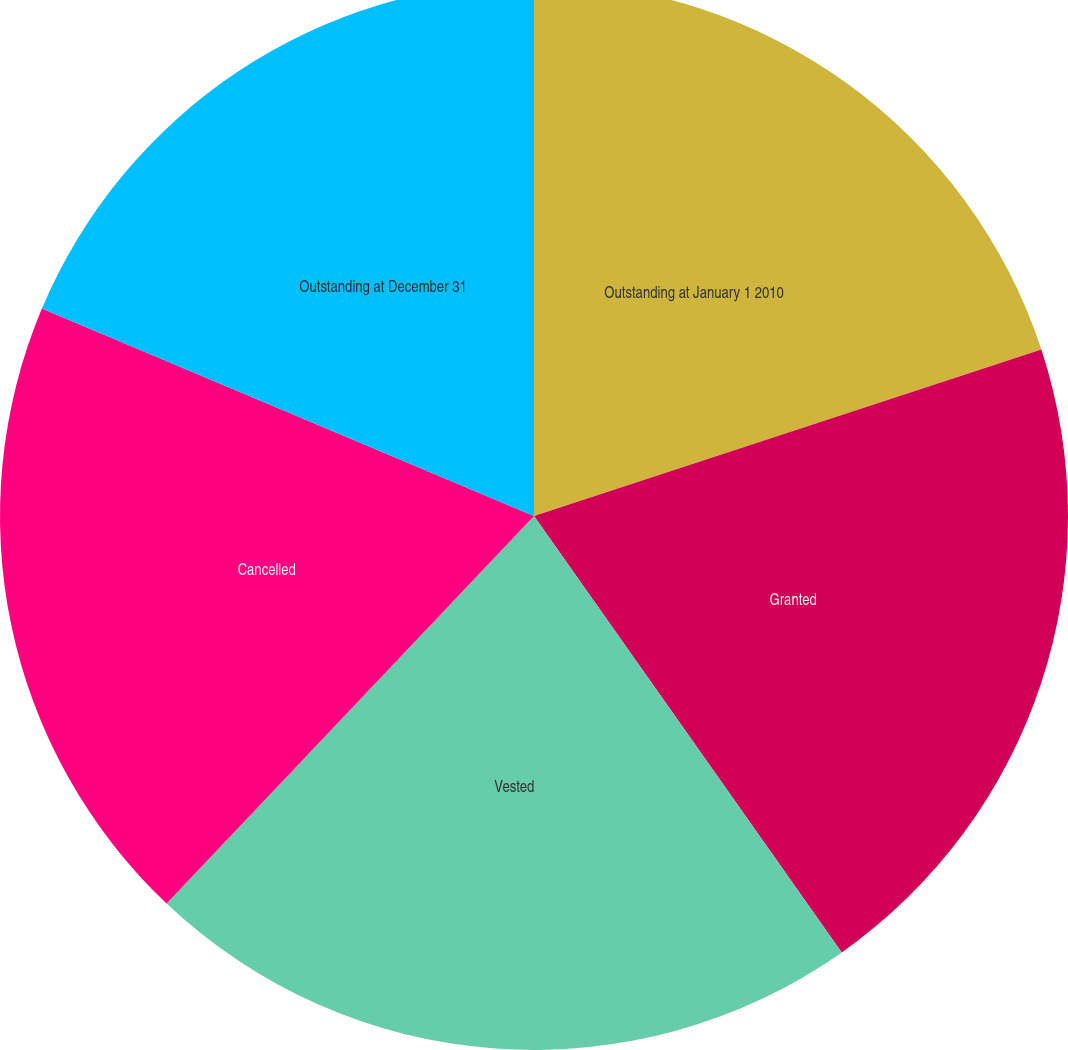Convert chart. <chart><loc_0><loc_0><loc_500><loc_500><pie_chart><fcel>Outstanding at January 1 2010<fcel>Granted<fcel>Vested<fcel>Cancelled<fcel>Outstanding at December 31<nl><fcel>19.95%<fcel>20.27%<fcel>21.85%<fcel>19.27%<fcel>18.65%<nl></chart> 